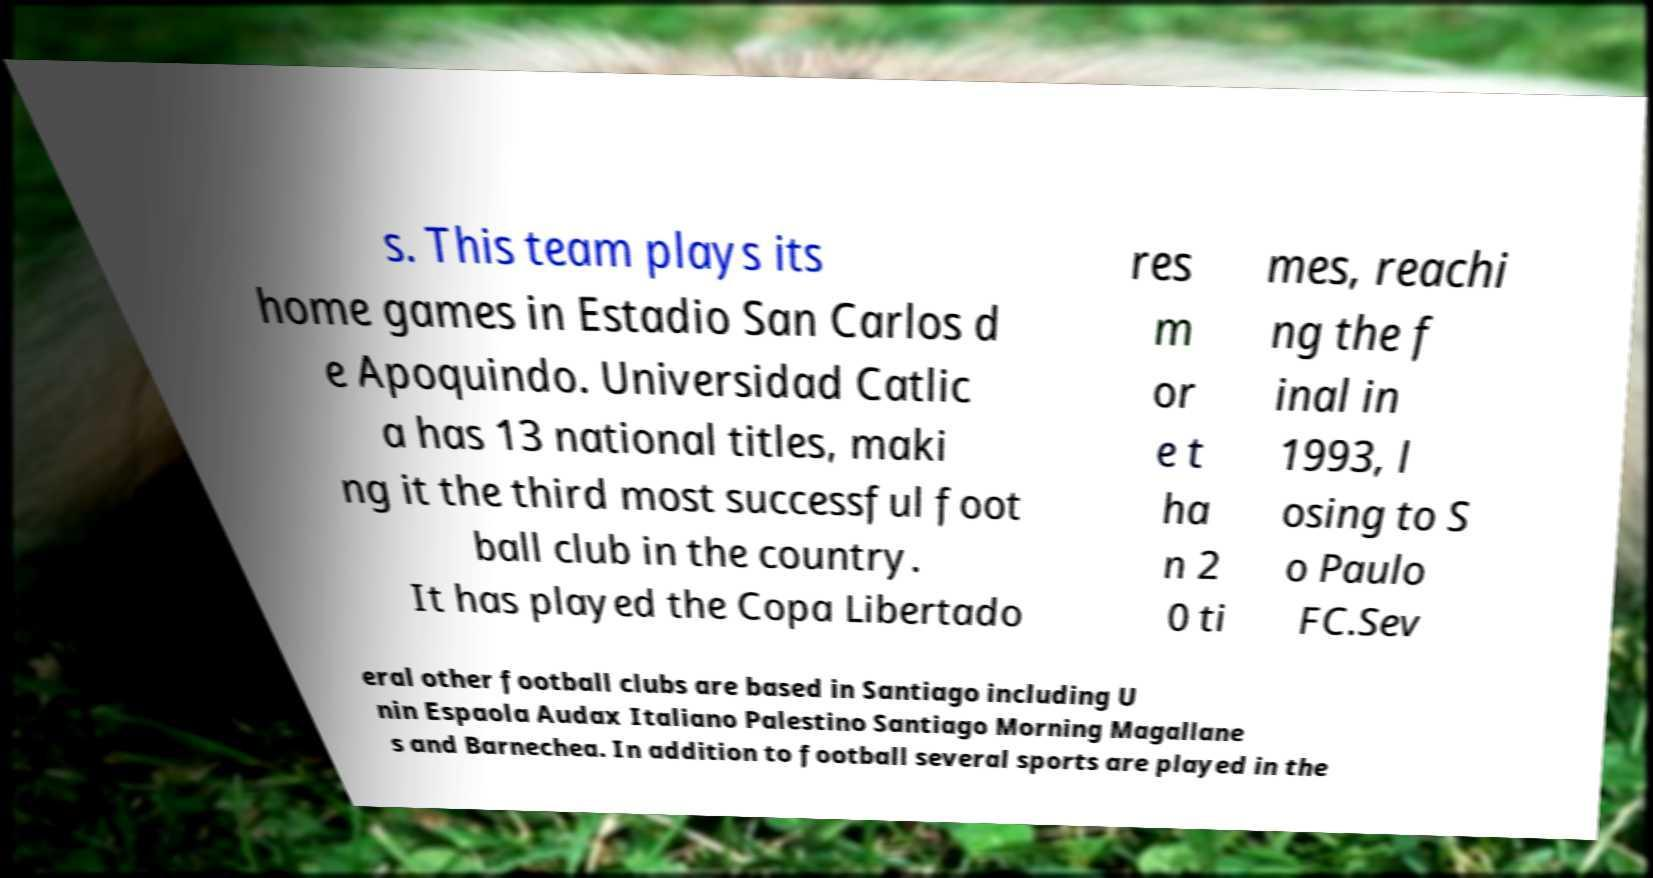There's text embedded in this image that I need extracted. Can you transcribe it verbatim? s. This team plays its home games in Estadio San Carlos d e Apoquindo. Universidad Catlic a has 13 national titles, maki ng it the third most successful foot ball club in the country. It has played the Copa Libertado res m or e t ha n 2 0 ti mes, reachi ng the f inal in 1993, l osing to S o Paulo FC.Sev eral other football clubs are based in Santiago including U nin Espaola Audax Italiano Palestino Santiago Morning Magallane s and Barnechea. In addition to football several sports are played in the 